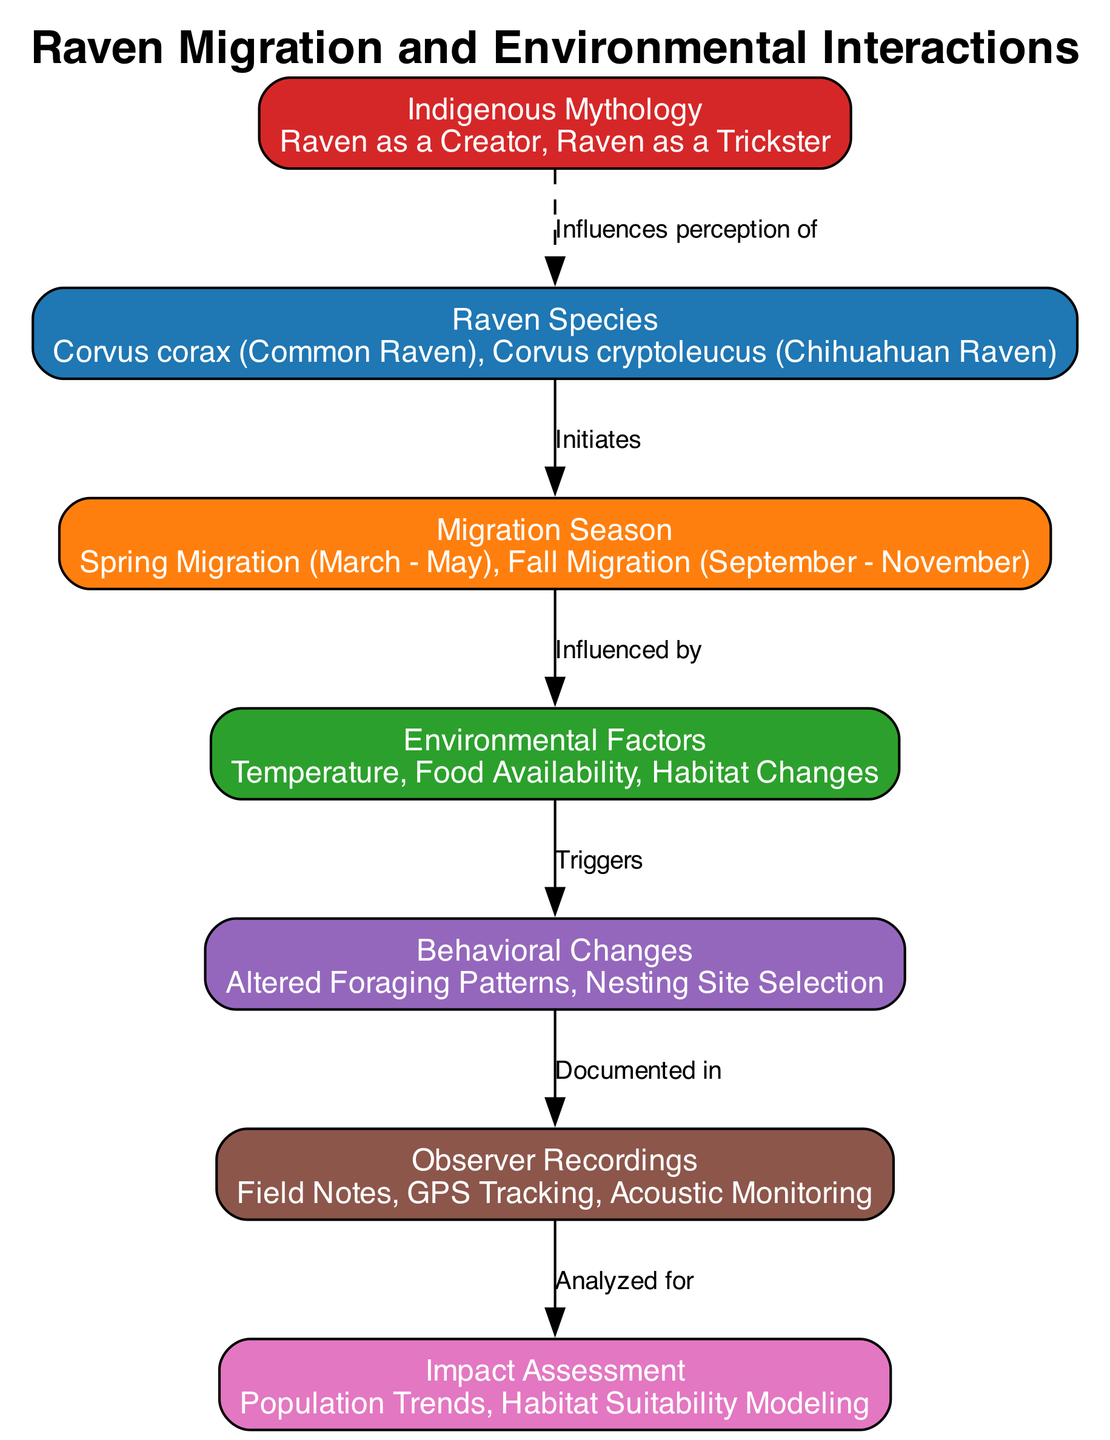What are the two raven species listed in the diagram? The diagram specifies two species: Corvus corax and Corvus cryptoleucus. This information can be found clearly represented in the node labeled "Raven Species."
Answer: Corvus corax, Corvus cryptoleucus How many migration seasons are identified in the diagram? The diagram states there are two migration seasons: Spring Migration and Fall Migration. This can be found under the "Migration Season" node.
Answer: 2 What environmental factors influence raven behavior? The diagram outlines three environmental factors: Temperature, Food Availability, and Habitat Changes, which are listed under the "Environmental Factors" node.
Answer: Temperature, Food Availability, Habitat Changes What triggers behavioral changes in ravens? According to the diagram, the behavior changes are triggered by environmental factors. This can be seen as an arrow pointing from "Environmental Factors" to "Behavioral Changes."
Answer: Environmental Factors How are behavioural changes documented? The diagram indicates that the behavioral changes are documented through observer recordings. This is directly represented in the flow going from "Behavioral Changes" to "Observer Recordings."
Answer: Observer Recordings What type of analysis is connected to observer recordings? The diagram shows that impacts from observer recordings lead to impact assessment, as indicated by the arrow from "Observer Recordings" to "Impact Assessment."
Answer: Impact Assessment Which element influences the perception of raven species? The diagram includes a dashed arrow from "Indigenous Mythology" to "Raven Species," indicating that Indigenous mythology influences how people perceive the different raven species.
Answer: Indigenous Mythology What kind of changes occur in the raven's behavior during migration? The diagram specifies "Altered Foraging Patterns" and "Nesting Site Selection" as the behavioral changes resulting from environmental influences during migration.
Answer: Altered Foraging Patterns, Nesting Site Selection How many edges are visible in the diagram? The diagram shows a total of six connections (edges) between different nodes. This can be counted by reviewing the arrows and their respective relationships in the sequence outlined.
Answer: 6 What is the primary action that leads to impact assessment? The primary action leading to impact assessment is the documentation of behavioral changes through observer recordings. This is depicted by the flow from "Observer Recordings" to "Impact Assessment."
Answer: Observer Recordings 